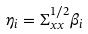Convert formula to latex. <formula><loc_0><loc_0><loc_500><loc_500>\eta _ { i } = \Sigma _ { x x } ^ { 1 / 2 } \beta _ { i }</formula> 